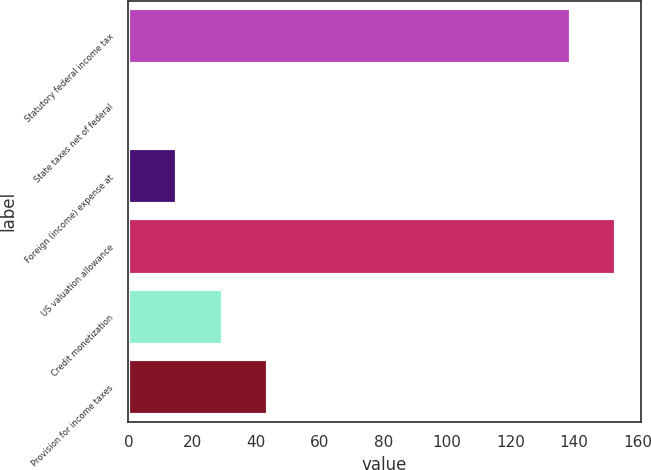Convert chart to OTSL. <chart><loc_0><loc_0><loc_500><loc_500><bar_chart><fcel>Statutory federal income tax<fcel>State taxes net of federal<fcel>Foreign (income) expense at<fcel>US valuation allowance<fcel>Credit monetization<fcel>Provision for income taxes<nl><fcel>139<fcel>1<fcel>15.3<fcel>153.3<fcel>29.6<fcel>43.9<nl></chart> 